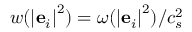<formula> <loc_0><loc_0><loc_500><loc_500>w ( { \left | { { { e } _ { i } } } \right | ^ { 2 } } ) = \omega ( { \left | { { { e } _ { i } } } \right | ^ { 2 } } ) / c _ { s } ^ { 2 }</formula> 